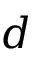Convert formula to latex. <formula><loc_0><loc_0><loc_500><loc_500>d</formula> 